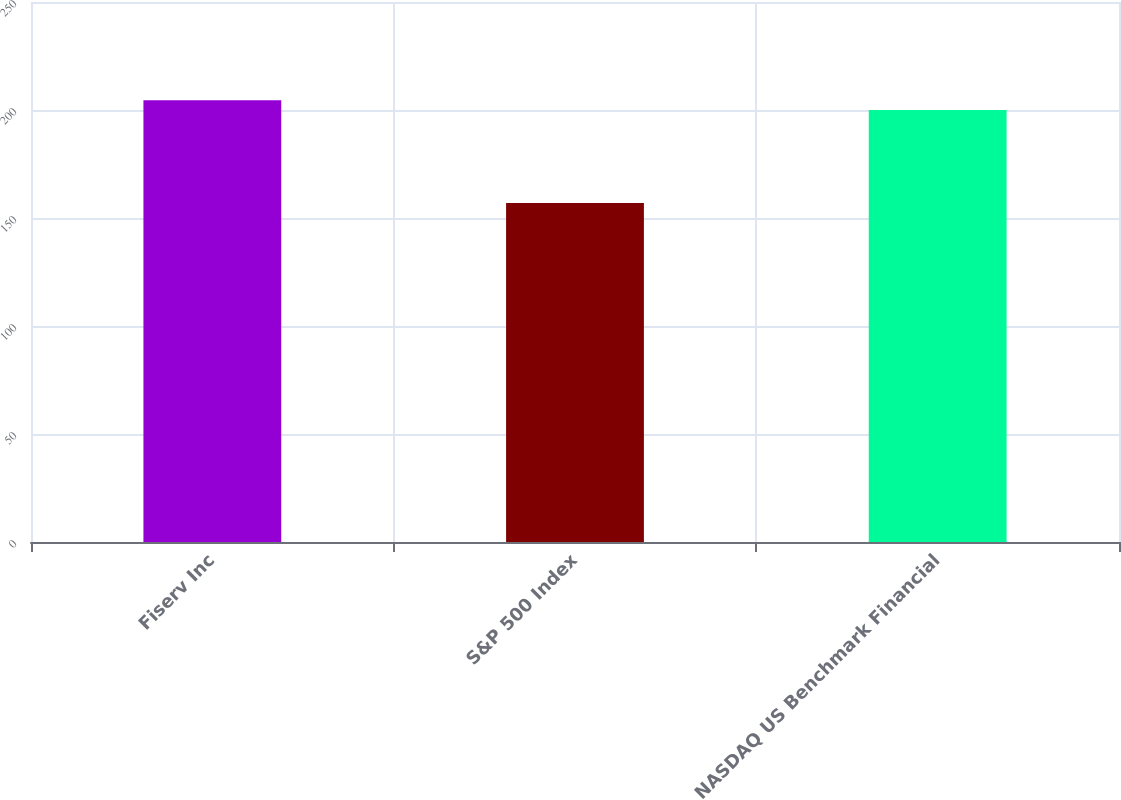<chart> <loc_0><loc_0><loc_500><loc_500><bar_chart><fcel>Fiserv Inc<fcel>S&P 500 Index<fcel>NASDAQ US Benchmark Financial<nl><fcel>204.5<fcel>157<fcel>200<nl></chart> 